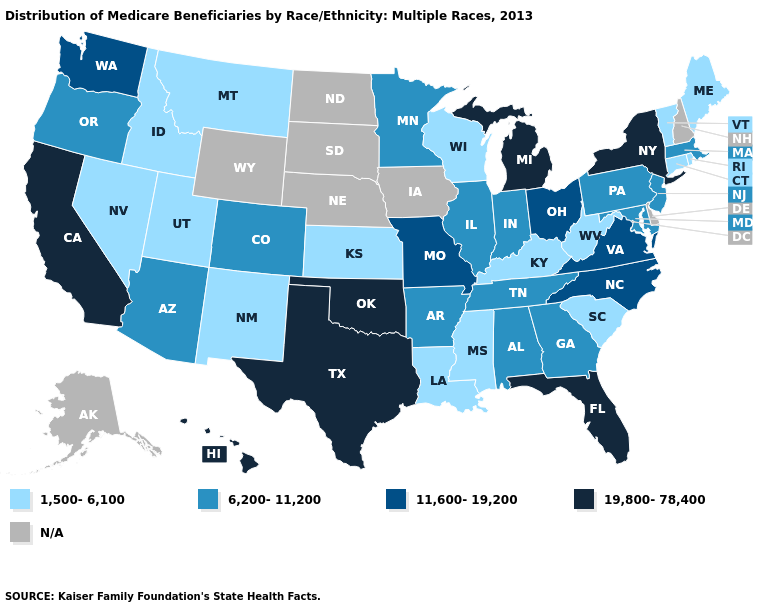Which states have the lowest value in the West?
Answer briefly. Idaho, Montana, Nevada, New Mexico, Utah. Name the states that have a value in the range 6,200-11,200?
Be succinct. Alabama, Arizona, Arkansas, Colorado, Georgia, Illinois, Indiana, Maryland, Massachusetts, Minnesota, New Jersey, Oregon, Pennsylvania, Tennessee. Name the states that have a value in the range 6,200-11,200?
Answer briefly. Alabama, Arizona, Arkansas, Colorado, Georgia, Illinois, Indiana, Maryland, Massachusetts, Minnesota, New Jersey, Oregon, Pennsylvania, Tennessee. Name the states that have a value in the range 19,800-78,400?
Write a very short answer. California, Florida, Hawaii, Michigan, New York, Oklahoma, Texas. Name the states that have a value in the range 19,800-78,400?
Concise answer only. California, Florida, Hawaii, Michigan, New York, Oklahoma, Texas. What is the value of Indiana?
Keep it brief. 6,200-11,200. Among the states that border Louisiana , does Texas have the highest value?
Concise answer only. Yes. Name the states that have a value in the range 6,200-11,200?
Write a very short answer. Alabama, Arizona, Arkansas, Colorado, Georgia, Illinois, Indiana, Maryland, Massachusetts, Minnesota, New Jersey, Oregon, Pennsylvania, Tennessee. What is the lowest value in states that border California?
Be succinct. 1,500-6,100. What is the value of Iowa?
Give a very brief answer. N/A. Name the states that have a value in the range 1,500-6,100?
Give a very brief answer. Connecticut, Idaho, Kansas, Kentucky, Louisiana, Maine, Mississippi, Montana, Nevada, New Mexico, Rhode Island, South Carolina, Utah, Vermont, West Virginia, Wisconsin. Among the states that border New York , which have the highest value?
Be succinct. Massachusetts, New Jersey, Pennsylvania. 